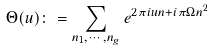Convert formula to latex. <formula><loc_0><loc_0><loc_500><loc_500>\Theta ( u ) \colon = \sum _ { n _ { 1 } , \cdots , n _ { g } } e ^ { 2 \pi i u n + i \pi \Omega n ^ { 2 } }</formula> 